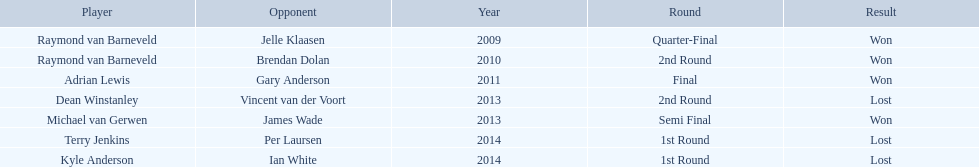Did terry jenkins win in 2014? Terry Jenkins, Lost. If terry jenkins lost who won? Per Laursen. 